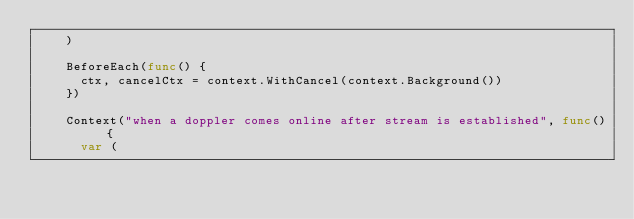Convert code to text. <code><loc_0><loc_0><loc_500><loc_500><_Go_>		)

		BeforeEach(func() {
			ctx, cancelCtx = context.WithCancel(context.Background())
		})

		Context("when a doppler comes online after stream is established", func() {
			var (</code> 